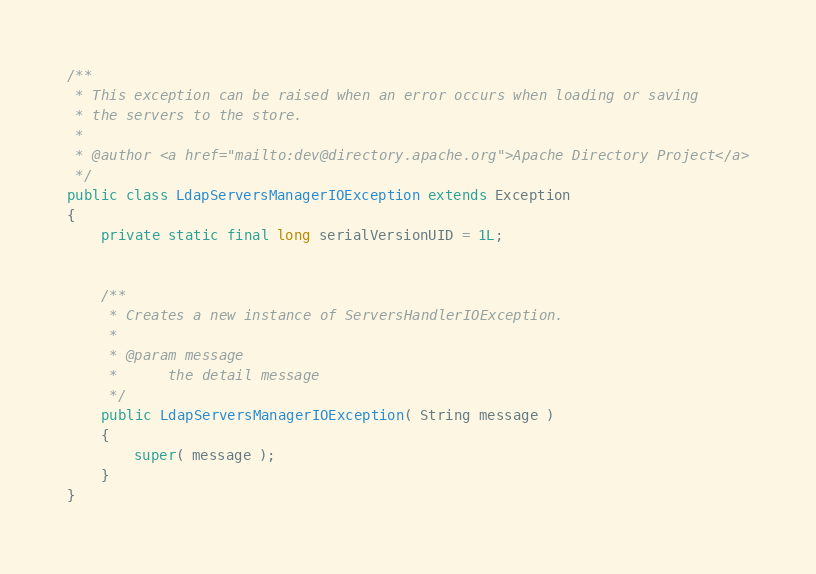Convert code to text. <code><loc_0><loc_0><loc_500><loc_500><_Java_>
/**
 * This exception can be raised when an error occurs when loading or saving 
 * the servers to the store.
 *
 * @author <a href="mailto:dev@directory.apache.org">Apache Directory Project</a>
 */
public class LdapServersManagerIOException extends Exception
{
    private static final long serialVersionUID = 1L;


    /**
     * Creates a new instance of ServersHandlerIOException.
     *
     * @param message
     *      the detail message
     */
    public LdapServersManagerIOException( String message )
    {
        super( message );
    }
}
</code> 